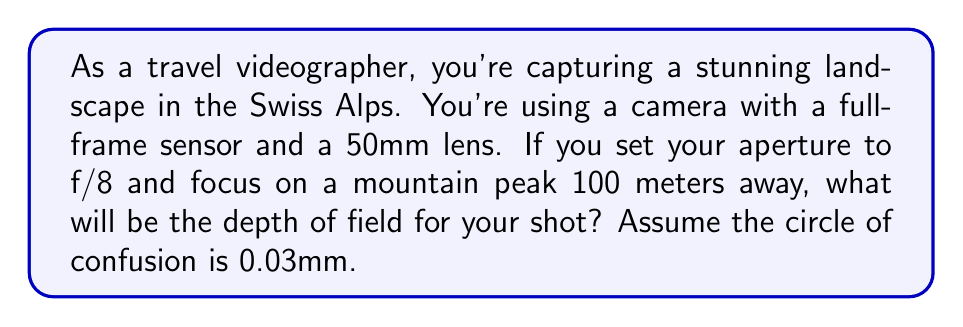What is the answer to this math problem? To calculate the depth of field, we'll use the following steps:

1. Calculate the hyperfocal distance:
   $$H = \frac{f^2}{N \cdot c} + f$$
   where $f$ is focal length, $N$ is f-number, and $c$ is circle of confusion.

   $$H = \frac{50^2}{8 \cdot 0.03} + 50 = 10,416.67 \text{ mm} \approx 10.42 \text{ m}$$

2. Calculate the near limit of acceptable sharpness:
   $$D_n = \frac{s \cdot (H - f)}{H + s - 2f}$$
   where $s$ is the subject distance.

   $$D_n = \frac{100,000 \cdot (10,416.67 - 50)}{10,416.67 + 100,000 - 2(50)} = 9,401.71 \text{ mm} \approx 9.40 \text{ m}$$

3. Calculate the far limit of acceptable sharpness:
   $$D_f = \frac{s \cdot (H - f)}{H - s}$$

   $$D_f = \frac{100,000 \cdot (10,416.67 - 50)}{10,416.67 - 100,000} = -11,628.57 \text{ mm}$$

   Since this value is negative, we consider the far limit to be at infinity.

4. Calculate the depth of field:
   DOF = Far limit - Near limit
   In this case, DOF = $\infty - 9.40 \text{ m} = \infty$

Therefore, the depth of field extends from 9.40 meters to infinity.
Answer: 9.40 m to $\infty$ 